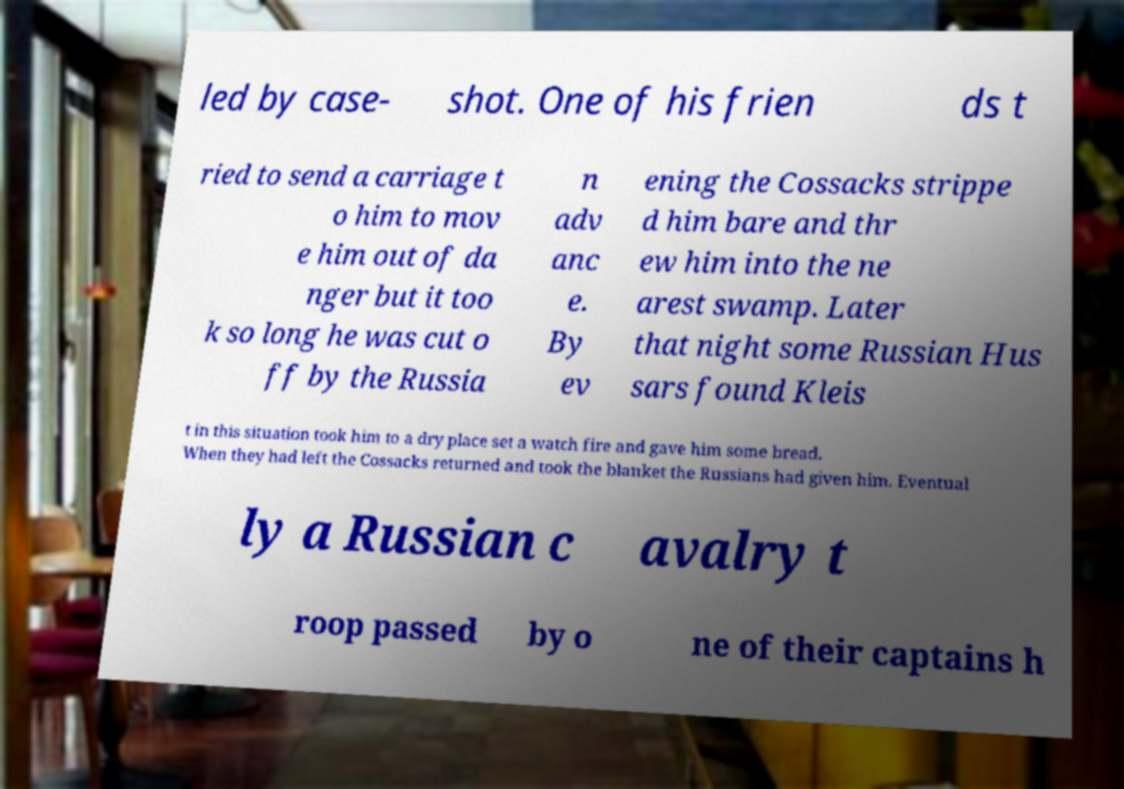Please read and relay the text visible in this image. What does it say? led by case- shot. One of his frien ds t ried to send a carriage t o him to mov e him out of da nger but it too k so long he was cut o ff by the Russia n adv anc e. By ev ening the Cossacks strippe d him bare and thr ew him into the ne arest swamp. Later that night some Russian Hus sars found Kleis t in this situation took him to a dry place set a watch fire and gave him some bread. When they had left the Cossacks returned and took the blanket the Russians had given him. Eventual ly a Russian c avalry t roop passed by o ne of their captains h 